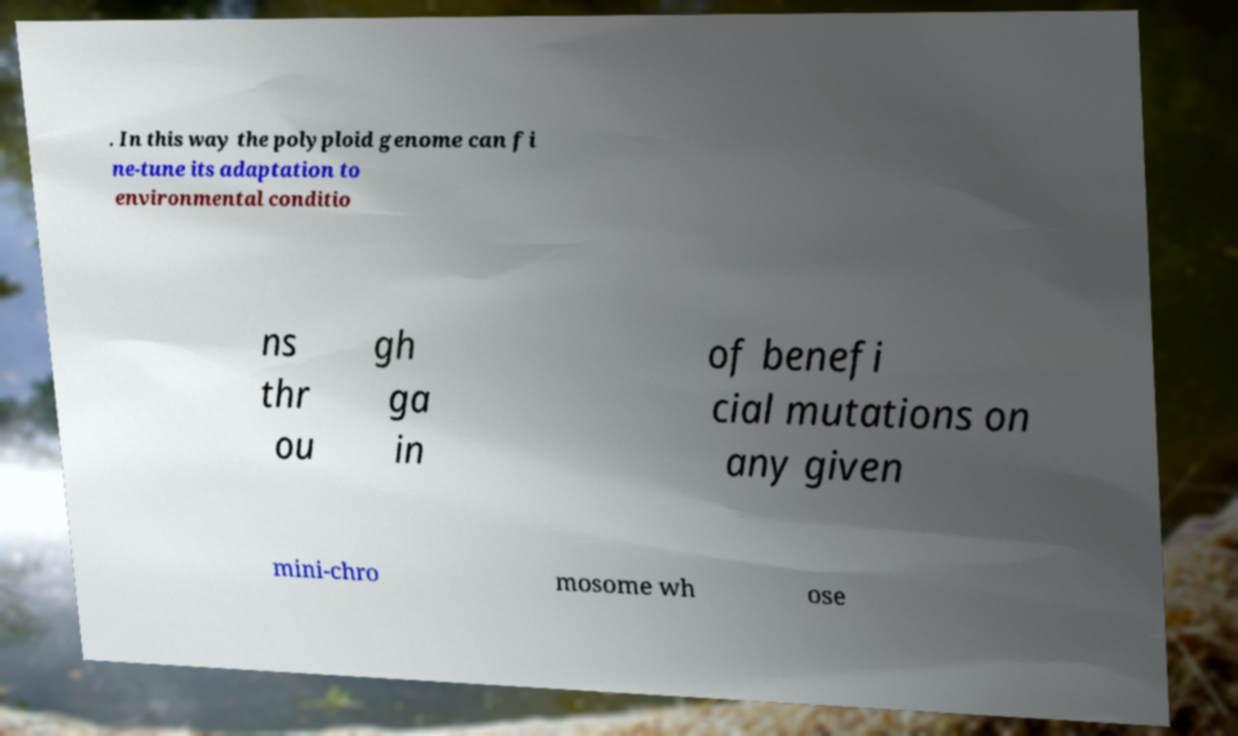There's text embedded in this image that I need extracted. Can you transcribe it verbatim? . In this way the polyploid genome can fi ne-tune its adaptation to environmental conditio ns thr ou gh ga in of benefi cial mutations on any given mini-chro mosome wh ose 